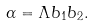<formula> <loc_0><loc_0><loc_500><loc_500>\alpha = \Lambda b _ { 1 } b _ { 2 } .</formula> 